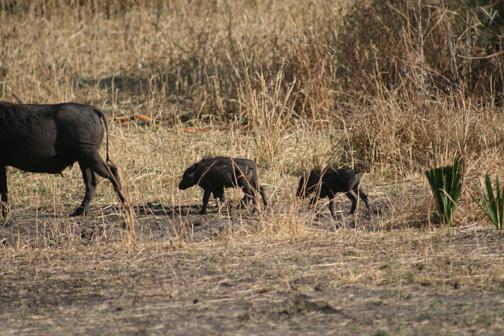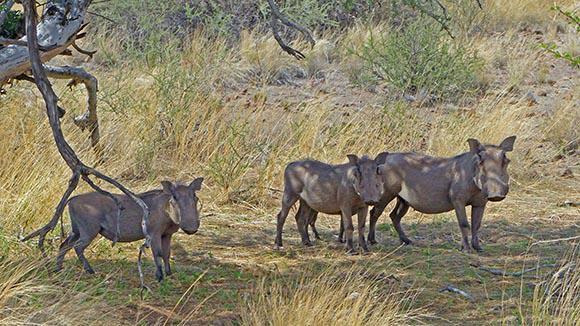The first image is the image on the left, the second image is the image on the right. Analyze the images presented: Is the assertion "The animals in one of the images are near a wet area." valid? Answer yes or no. No. 